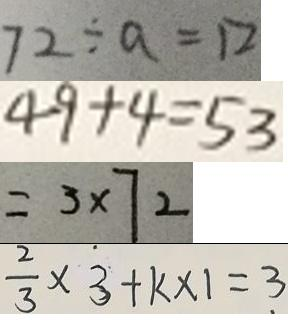<formula> <loc_0><loc_0><loc_500><loc_500>7 2 \div a = 1 2 
 4 9 + 4 = 5 3 
 = 3 \times 7 2 
 \frac { 2 } { 3 } \times 3 + k \times 1 = 3</formula> 